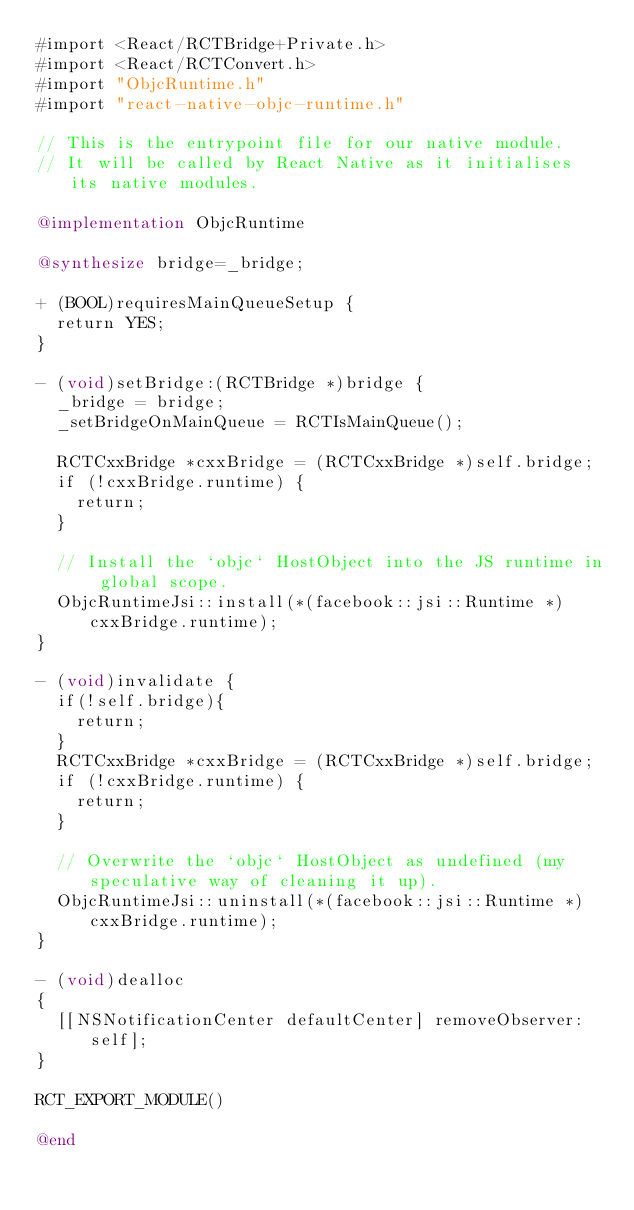<code> <loc_0><loc_0><loc_500><loc_500><_ObjectiveC_>#import <React/RCTBridge+Private.h>
#import <React/RCTConvert.h>
#import "ObjcRuntime.h"
#import "react-native-objc-runtime.h"

// This is the entrypoint file for our native module.
// It will be called by React Native as it initialises its native modules.

@implementation ObjcRuntime

@synthesize bridge=_bridge;

+ (BOOL)requiresMainQueueSetup {
  return YES;
}

- (void)setBridge:(RCTBridge *)bridge {
  _bridge = bridge;
  _setBridgeOnMainQueue = RCTIsMainQueue();

  RCTCxxBridge *cxxBridge = (RCTCxxBridge *)self.bridge;
  if (!cxxBridge.runtime) {
    return;
  }
  
  // Install the `objc` HostObject into the JS runtime in global scope.
  ObjcRuntimeJsi::install(*(facebook::jsi::Runtime *)cxxBridge.runtime);
}

- (void)invalidate {
  if(!self.bridge){
    return;
  }
  RCTCxxBridge *cxxBridge = (RCTCxxBridge *)self.bridge;
  if (!cxxBridge.runtime) {
    return;
  }
  
  // Overwrite the `objc` HostObject as undefined (my speculative way of cleaning it up).
  ObjcRuntimeJsi::uninstall(*(facebook::jsi::Runtime *)cxxBridge.runtime);
}

- (void)dealloc
{
  [[NSNotificationCenter defaultCenter] removeObserver:self];
}

RCT_EXPORT_MODULE()

@end
</code> 